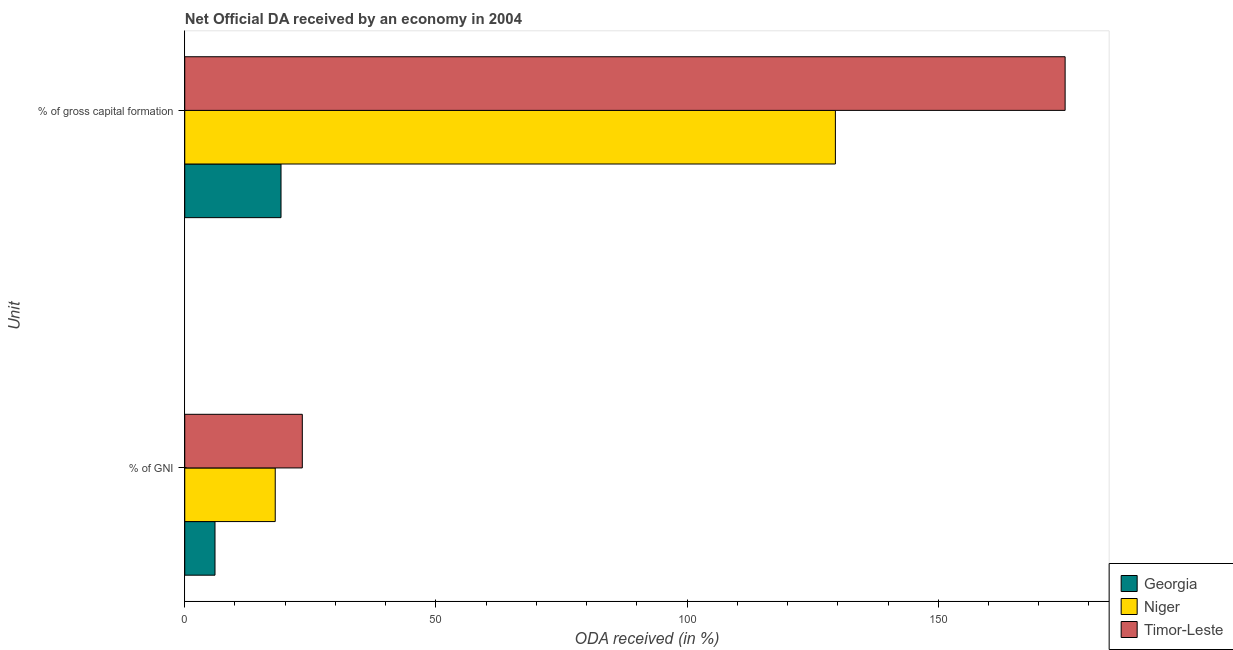How many different coloured bars are there?
Offer a very short reply. 3. How many groups of bars are there?
Your answer should be compact. 2. Are the number of bars per tick equal to the number of legend labels?
Make the answer very short. Yes. Are the number of bars on each tick of the Y-axis equal?
Your response must be concise. Yes. How many bars are there on the 1st tick from the top?
Give a very brief answer. 3. What is the label of the 2nd group of bars from the top?
Give a very brief answer. % of GNI. What is the oda received as percentage of gross capital formation in Timor-Leste?
Give a very brief answer. 175.26. Across all countries, what is the maximum oda received as percentage of gni?
Your response must be concise. 23.4. Across all countries, what is the minimum oda received as percentage of gross capital formation?
Your response must be concise. 19.16. In which country was the oda received as percentage of gross capital formation maximum?
Your answer should be compact. Timor-Leste. In which country was the oda received as percentage of gni minimum?
Make the answer very short. Georgia. What is the total oda received as percentage of gross capital formation in the graph?
Offer a very short reply. 323.95. What is the difference between the oda received as percentage of gross capital formation in Niger and that in Georgia?
Your answer should be compact. 110.36. What is the difference between the oda received as percentage of gross capital formation in Georgia and the oda received as percentage of gni in Timor-Leste?
Offer a very short reply. -4.24. What is the average oda received as percentage of gni per country?
Your response must be concise. 15.81. What is the difference between the oda received as percentage of gross capital formation and oda received as percentage of gni in Niger?
Ensure brevity in your answer.  111.51. What is the ratio of the oda received as percentage of gross capital formation in Georgia to that in Timor-Leste?
Keep it short and to the point. 0.11. What does the 1st bar from the top in % of GNI represents?
Your answer should be very brief. Timor-Leste. What does the 1st bar from the bottom in % of GNI represents?
Give a very brief answer. Georgia. How many bars are there?
Provide a succinct answer. 6. Are all the bars in the graph horizontal?
Offer a terse response. Yes. How many countries are there in the graph?
Make the answer very short. 3. Are the values on the major ticks of X-axis written in scientific E-notation?
Provide a short and direct response. No. How are the legend labels stacked?
Your response must be concise. Vertical. What is the title of the graph?
Offer a very short reply. Net Official DA received by an economy in 2004. What is the label or title of the X-axis?
Give a very brief answer. ODA received (in %). What is the label or title of the Y-axis?
Your answer should be compact. Unit. What is the ODA received (in %) in Georgia in % of GNI?
Provide a succinct answer. 6.02. What is the ODA received (in %) in Niger in % of GNI?
Offer a terse response. 18.01. What is the ODA received (in %) of Timor-Leste in % of GNI?
Your answer should be compact. 23.4. What is the ODA received (in %) of Georgia in % of gross capital formation?
Give a very brief answer. 19.16. What is the ODA received (in %) of Niger in % of gross capital formation?
Provide a short and direct response. 129.53. What is the ODA received (in %) of Timor-Leste in % of gross capital formation?
Provide a succinct answer. 175.26. Across all Unit, what is the maximum ODA received (in %) of Georgia?
Your answer should be compact. 19.16. Across all Unit, what is the maximum ODA received (in %) of Niger?
Make the answer very short. 129.53. Across all Unit, what is the maximum ODA received (in %) in Timor-Leste?
Ensure brevity in your answer.  175.26. Across all Unit, what is the minimum ODA received (in %) of Georgia?
Your answer should be compact. 6.02. Across all Unit, what is the minimum ODA received (in %) of Niger?
Offer a terse response. 18.01. Across all Unit, what is the minimum ODA received (in %) in Timor-Leste?
Your response must be concise. 23.4. What is the total ODA received (in %) of Georgia in the graph?
Provide a succinct answer. 25.19. What is the total ODA received (in %) in Niger in the graph?
Your response must be concise. 147.54. What is the total ODA received (in %) of Timor-Leste in the graph?
Give a very brief answer. 198.66. What is the difference between the ODA received (in %) in Georgia in % of GNI and that in % of gross capital formation?
Offer a very short reply. -13.14. What is the difference between the ODA received (in %) of Niger in % of GNI and that in % of gross capital formation?
Your answer should be very brief. -111.51. What is the difference between the ODA received (in %) in Timor-Leste in % of GNI and that in % of gross capital formation?
Keep it short and to the point. -151.86. What is the difference between the ODA received (in %) in Georgia in % of GNI and the ODA received (in %) in Niger in % of gross capital formation?
Ensure brevity in your answer.  -123.5. What is the difference between the ODA received (in %) in Georgia in % of GNI and the ODA received (in %) in Timor-Leste in % of gross capital formation?
Make the answer very short. -169.24. What is the difference between the ODA received (in %) of Niger in % of GNI and the ODA received (in %) of Timor-Leste in % of gross capital formation?
Give a very brief answer. -157.25. What is the average ODA received (in %) of Georgia per Unit?
Provide a short and direct response. 12.59. What is the average ODA received (in %) in Niger per Unit?
Provide a succinct answer. 73.77. What is the average ODA received (in %) of Timor-Leste per Unit?
Make the answer very short. 99.33. What is the difference between the ODA received (in %) of Georgia and ODA received (in %) of Niger in % of GNI?
Keep it short and to the point. -11.99. What is the difference between the ODA received (in %) in Georgia and ODA received (in %) in Timor-Leste in % of GNI?
Your answer should be compact. -17.38. What is the difference between the ODA received (in %) in Niger and ODA received (in %) in Timor-Leste in % of GNI?
Keep it short and to the point. -5.39. What is the difference between the ODA received (in %) in Georgia and ODA received (in %) in Niger in % of gross capital formation?
Give a very brief answer. -110.36. What is the difference between the ODA received (in %) in Georgia and ODA received (in %) in Timor-Leste in % of gross capital formation?
Make the answer very short. -156.1. What is the difference between the ODA received (in %) in Niger and ODA received (in %) in Timor-Leste in % of gross capital formation?
Your answer should be compact. -45.73. What is the ratio of the ODA received (in %) in Georgia in % of GNI to that in % of gross capital formation?
Your answer should be very brief. 0.31. What is the ratio of the ODA received (in %) in Niger in % of GNI to that in % of gross capital formation?
Offer a very short reply. 0.14. What is the ratio of the ODA received (in %) in Timor-Leste in % of GNI to that in % of gross capital formation?
Your answer should be very brief. 0.13. What is the difference between the highest and the second highest ODA received (in %) of Georgia?
Provide a succinct answer. 13.14. What is the difference between the highest and the second highest ODA received (in %) in Niger?
Your answer should be compact. 111.51. What is the difference between the highest and the second highest ODA received (in %) of Timor-Leste?
Provide a short and direct response. 151.86. What is the difference between the highest and the lowest ODA received (in %) in Georgia?
Keep it short and to the point. 13.14. What is the difference between the highest and the lowest ODA received (in %) of Niger?
Offer a terse response. 111.51. What is the difference between the highest and the lowest ODA received (in %) in Timor-Leste?
Ensure brevity in your answer.  151.86. 